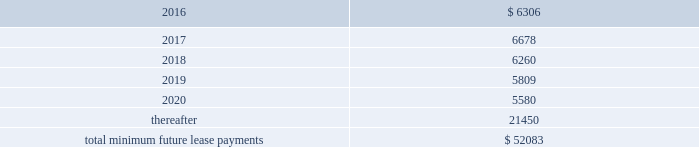Notes receivable in 2014 , we entered into a $ 3.0 million promissory note with a privately held company which was recorded at cost .
The interest rate on the promissory note is 8.0% ( 8.0 % ) per annum and is payable quarterly .
All unpaid principal and accrued interest on the promissory note is due and payable on the earlier of august 26 , 2017 , or upon default .
Commitments and contingencies operating leases we lease various operating spaces in north america , europe , asia and australia under non-cancelable operating lease arrangements that expire on various dates through 2024 .
These arrangements require us to pay certain operating expenses , such as taxes , repairs , and insurance and contain renewal and escalation clauses .
We recognize rent expense under these arrangements on a straight-line basis over the term of the lease .
As of december 31 , 2015 , the aggregate future minimum payments under non-cancelable operating leases consist of the following ( in thousands ) : years ending december 31 .
Rent expense for all operating leases amounted to $ 6.7 million , $ 3.3 million and $ 3.6 million for the years ended december 31 , 2015 , 2014 and 2013 , respectively .
Financing obligation 2014build-to-suit lease in august 2012 , we executed a lease for a building then under construction in santa clara , california to serve as our headquarters .
The lease term is 120 months and commenced in august 2013 .
Based on the terms of the lease agreement and due to our involvement in certain aspects of the construction such as our financial involvement in structural elements of asset construction , making decisions related to tenant improvement costs and purchasing insurance not reimbursable by the buyer-lessor ( the landlord ) , we were deemed the owner of the building ( for accounting purposes only ) during the construction period .
We continue to maintain involvement in the property post construction completion and lack transferability of the risks and rewards of ownership , due to our required maintenance of a $ 4.0 million letter of credit , in addition to our ability and option to sublease our portion of the leased building for fees substantially higher than our base rate .
Due to our continued involvement in the property and lack of transferability of related risks and rewards of ownership to the landlord post construction , we account for the building and related improvements as a lease financing obligation .
Accordingly , as of december 31 , 2015 and 2014 , we have recorded assets of $ 53.4 million , representing the total costs of the building and improvements incurred , including the costs paid by the lessor ( the legal owner of the building ) and additional improvement costs paid by us , and a corresponding financing obligation of $ 42.5 million and $ 43.6 million , respectively .
As of december 31 , 2015 , $ 1.3 million and $ 41.2 million were recorded as short-term and long-term financing obligations , respectively .
Land lease expense under our lease financing obligation included in rent expense above , amounted to $ 1.3 million and $ 1.2 million for the years ended december 31 , 2015 and 2014 , respectively .
There was no land lease expense for the year ended december 31 , 2013. .
What is the expected growth rate in the rent expense for operating leases in 2016? 
Computations: (((6306 / 1000) - 6.7) / 6.7)
Answer: -0.05881. Notes receivable in 2014 , we entered into a $ 3.0 million promissory note with a privately held company which was recorded at cost .
The interest rate on the promissory note is 8.0% ( 8.0 % ) per annum and is payable quarterly .
All unpaid principal and accrued interest on the promissory note is due and payable on the earlier of august 26 , 2017 , or upon default .
Commitments and contingencies operating leases we lease various operating spaces in north america , europe , asia and australia under non-cancelable operating lease arrangements that expire on various dates through 2024 .
These arrangements require us to pay certain operating expenses , such as taxes , repairs , and insurance and contain renewal and escalation clauses .
We recognize rent expense under these arrangements on a straight-line basis over the term of the lease .
As of december 31 , 2015 , the aggregate future minimum payments under non-cancelable operating leases consist of the following ( in thousands ) : years ending december 31 .
Rent expense for all operating leases amounted to $ 6.7 million , $ 3.3 million and $ 3.6 million for the years ended december 31 , 2015 , 2014 and 2013 , respectively .
Financing obligation 2014build-to-suit lease in august 2012 , we executed a lease for a building then under construction in santa clara , california to serve as our headquarters .
The lease term is 120 months and commenced in august 2013 .
Based on the terms of the lease agreement and due to our involvement in certain aspects of the construction such as our financial involvement in structural elements of asset construction , making decisions related to tenant improvement costs and purchasing insurance not reimbursable by the buyer-lessor ( the landlord ) , we were deemed the owner of the building ( for accounting purposes only ) during the construction period .
We continue to maintain involvement in the property post construction completion and lack transferability of the risks and rewards of ownership , due to our required maintenance of a $ 4.0 million letter of credit , in addition to our ability and option to sublease our portion of the leased building for fees substantially higher than our base rate .
Due to our continued involvement in the property and lack of transferability of related risks and rewards of ownership to the landlord post construction , we account for the building and related improvements as a lease financing obligation .
Accordingly , as of december 31 , 2015 and 2014 , we have recorded assets of $ 53.4 million , representing the total costs of the building and improvements incurred , including the costs paid by the lessor ( the legal owner of the building ) and additional improvement costs paid by us , and a corresponding financing obligation of $ 42.5 million and $ 43.6 million , respectively .
As of december 31 , 2015 , $ 1.3 million and $ 41.2 million were recorded as short-term and long-term financing obligations , respectively .
Land lease expense under our lease financing obligation included in rent expense above , amounted to $ 1.3 million and $ 1.2 million for the years ended december 31 , 2015 and 2014 , respectively .
There was no land lease expense for the year ended december 31 , 2013. .
What is the growth rate in the rent expense for operating leases in 2015? 
Computations: ((6.7 - 3.3) / 3.3)
Answer: 1.0303. 